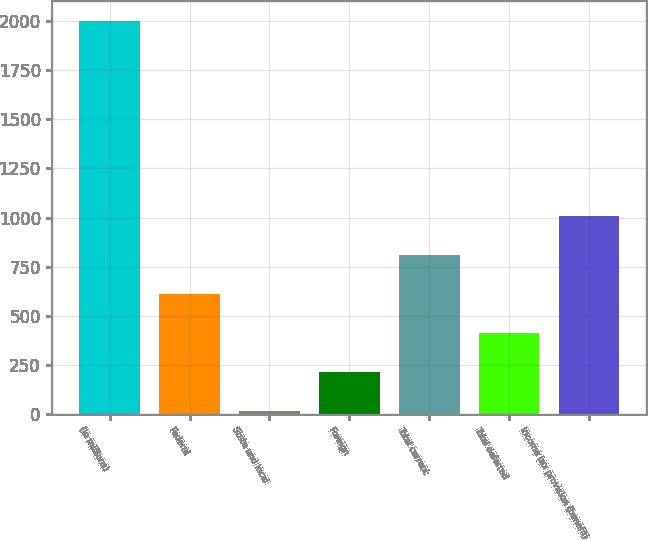Convert chart to OTSL. <chart><loc_0><loc_0><loc_500><loc_500><bar_chart><fcel>(In millions)<fcel>Federal<fcel>State and local<fcel>Foreign<fcel>Total current<fcel>Total deferred<fcel>Income tax provision (benefit)<nl><fcel>2004<fcel>611.7<fcel>15<fcel>213.9<fcel>810.6<fcel>412.8<fcel>1009.5<nl></chart> 